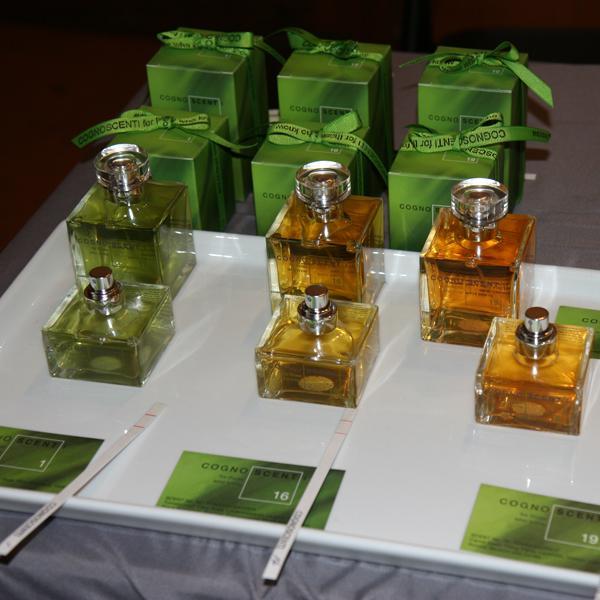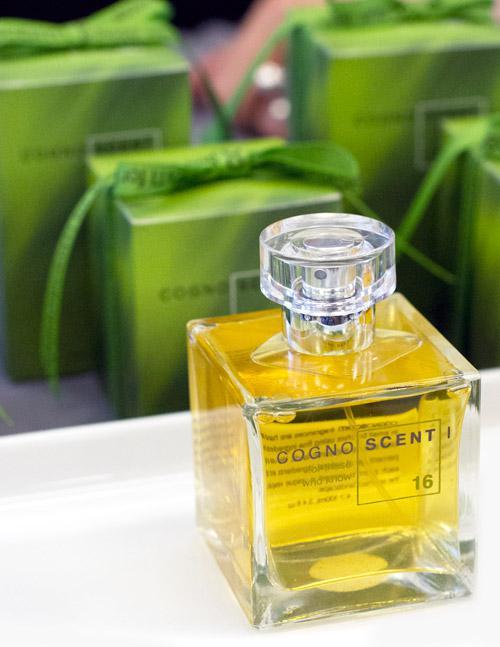The first image is the image on the left, the second image is the image on the right. Given the left and right images, does the statement "There are at least four bottles of perfume." hold true? Answer yes or no. Yes. The first image is the image on the left, the second image is the image on the right. Considering the images on both sides, is "There are at least five bottles of perfume." valid? Answer yes or no. Yes. 